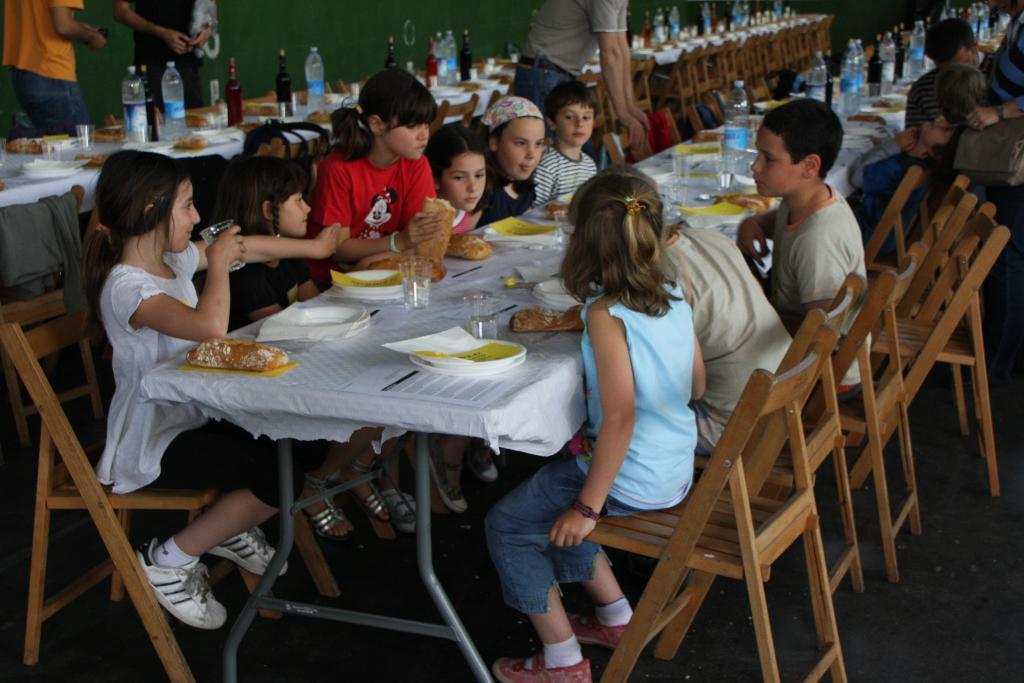Can you describe this image briefly? there are many children sitting on the chair with table in front of them. 